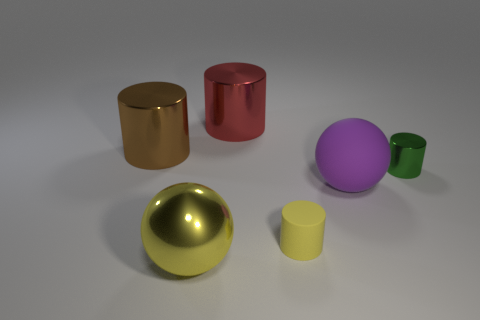Do the ball that is left of the red cylinder and the tiny matte thing have the same color?
Make the answer very short. Yes. There is a metal ball; is it the same color as the tiny matte cylinder behind the large yellow object?
Your answer should be very brief. Yes. Does the large yellow sphere have the same material as the yellow object that is to the right of the red cylinder?
Keep it short and to the point. No. What shape is the big shiny thing that is in front of the green cylinder?
Give a very brief answer. Sphere. Are there any other things of the same color as the small metallic cylinder?
Your answer should be very brief. No. Is the number of tiny yellow cylinders that are to the left of the brown metallic cylinder less than the number of brown shiny objects?
Ensure brevity in your answer.  Yes. How many green shiny cylinders have the same size as the yellow rubber cylinder?
Your response must be concise. 1. What shape is the large thing that is the same color as the small matte thing?
Your answer should be very brief. Sphere. What shape is the tiny thing behind the small thing that is in front of the metal cylinder that is to the right of the purple matte thing?
Offer a very short reply. Cylinder. There is a thing that is right of the rubber sphere; what color is it?
Your response must be concise. Green. 